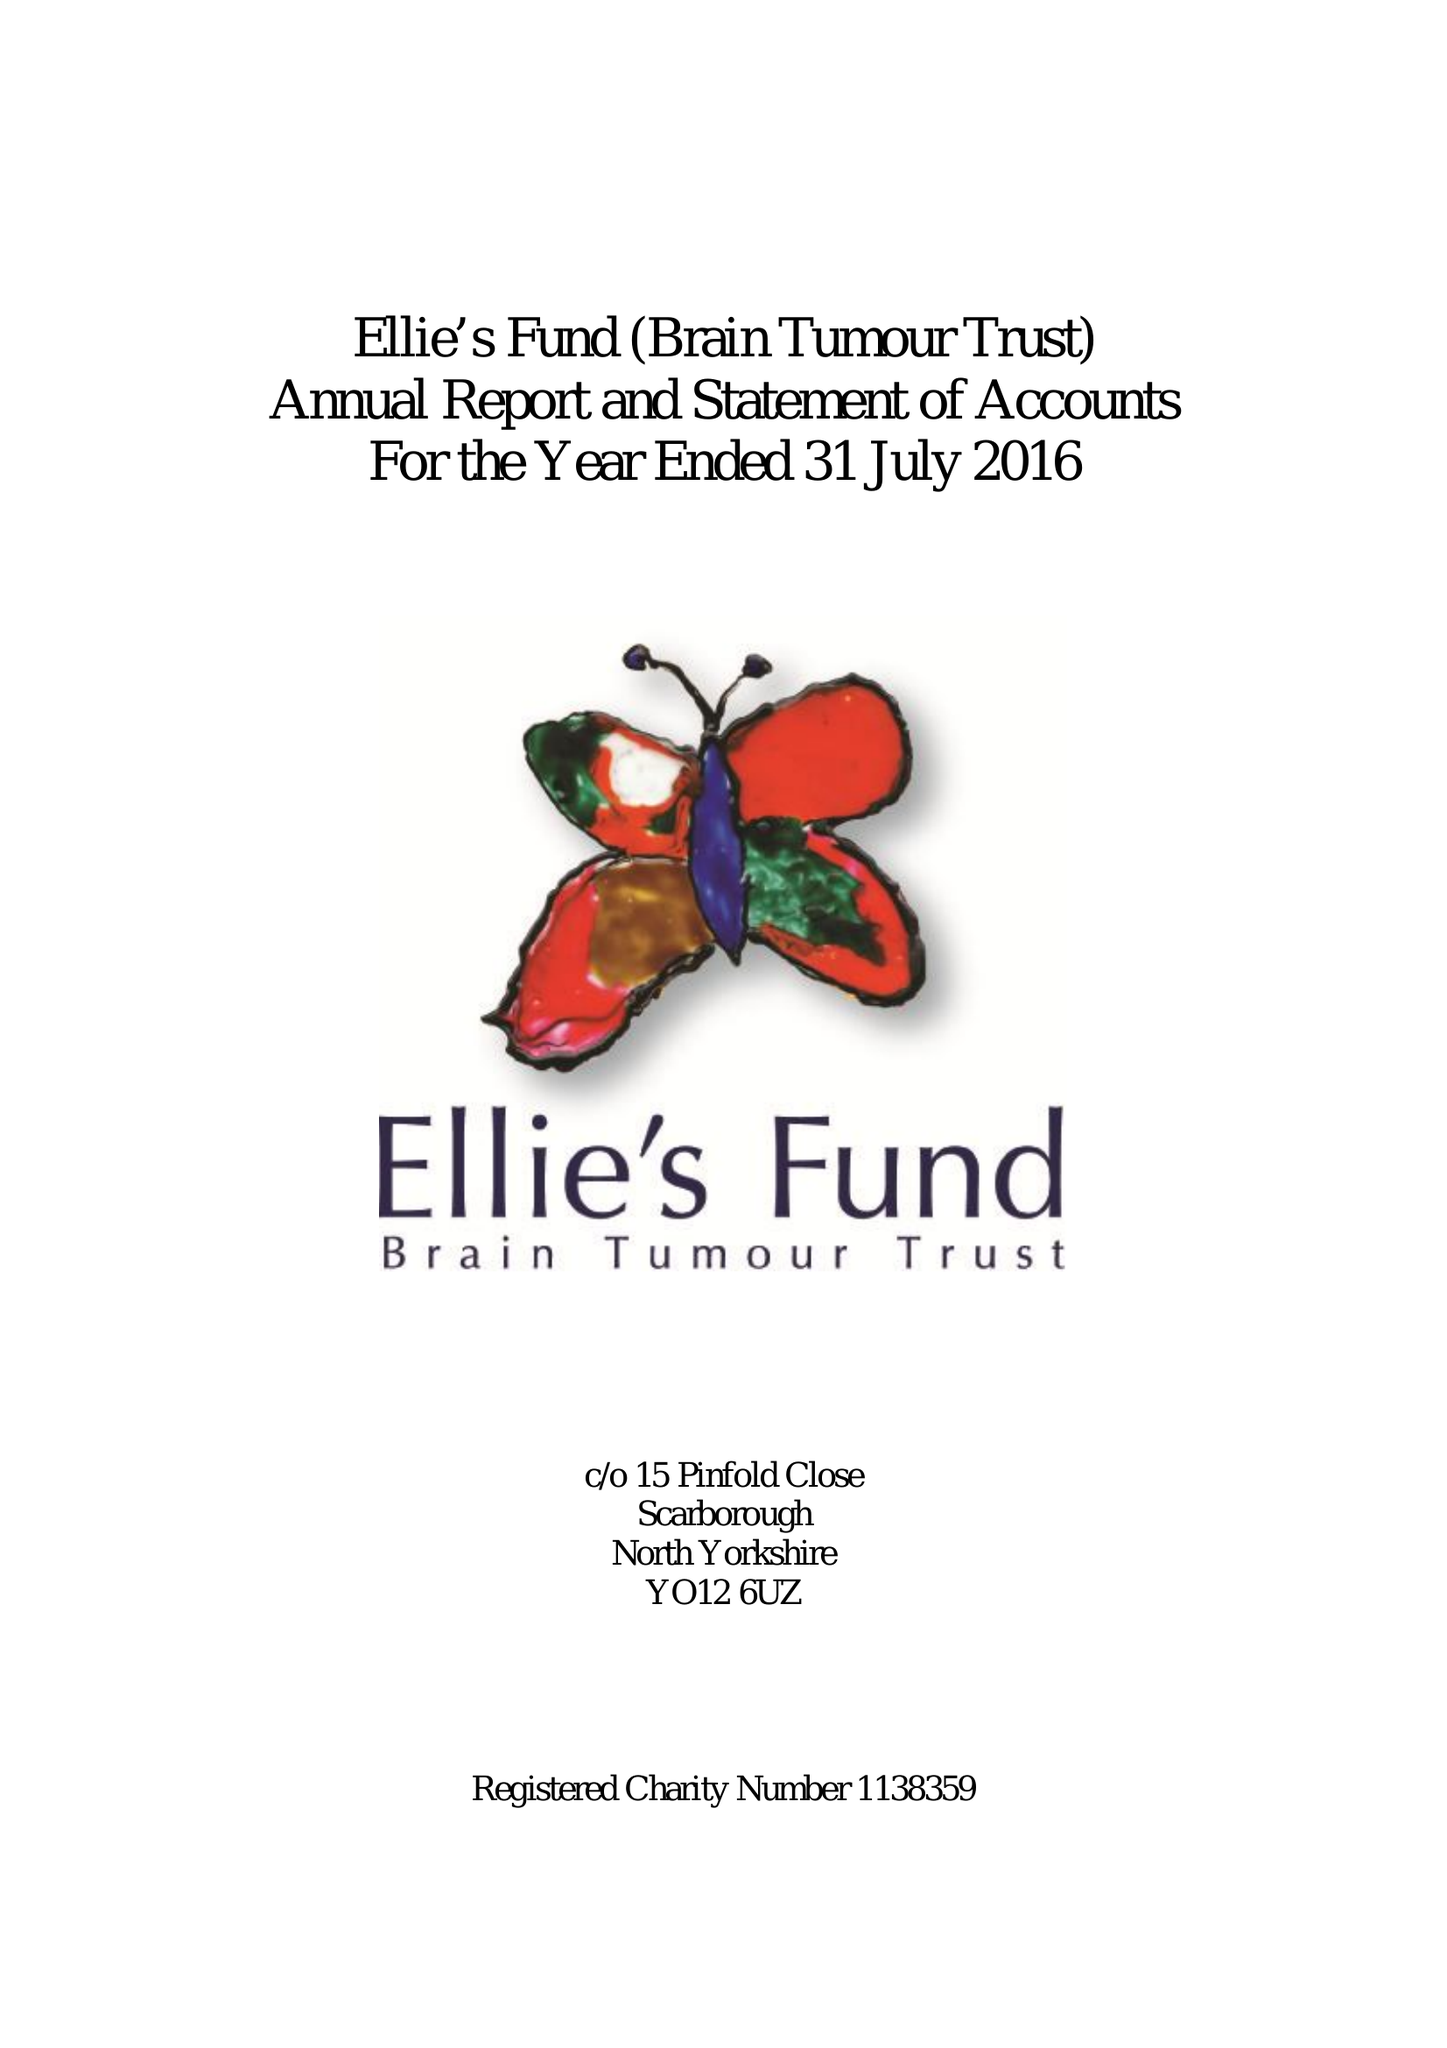What is the value for the spending_annually_in_british_pounds?
Answer the question using a single word or phrase. 21045.00 